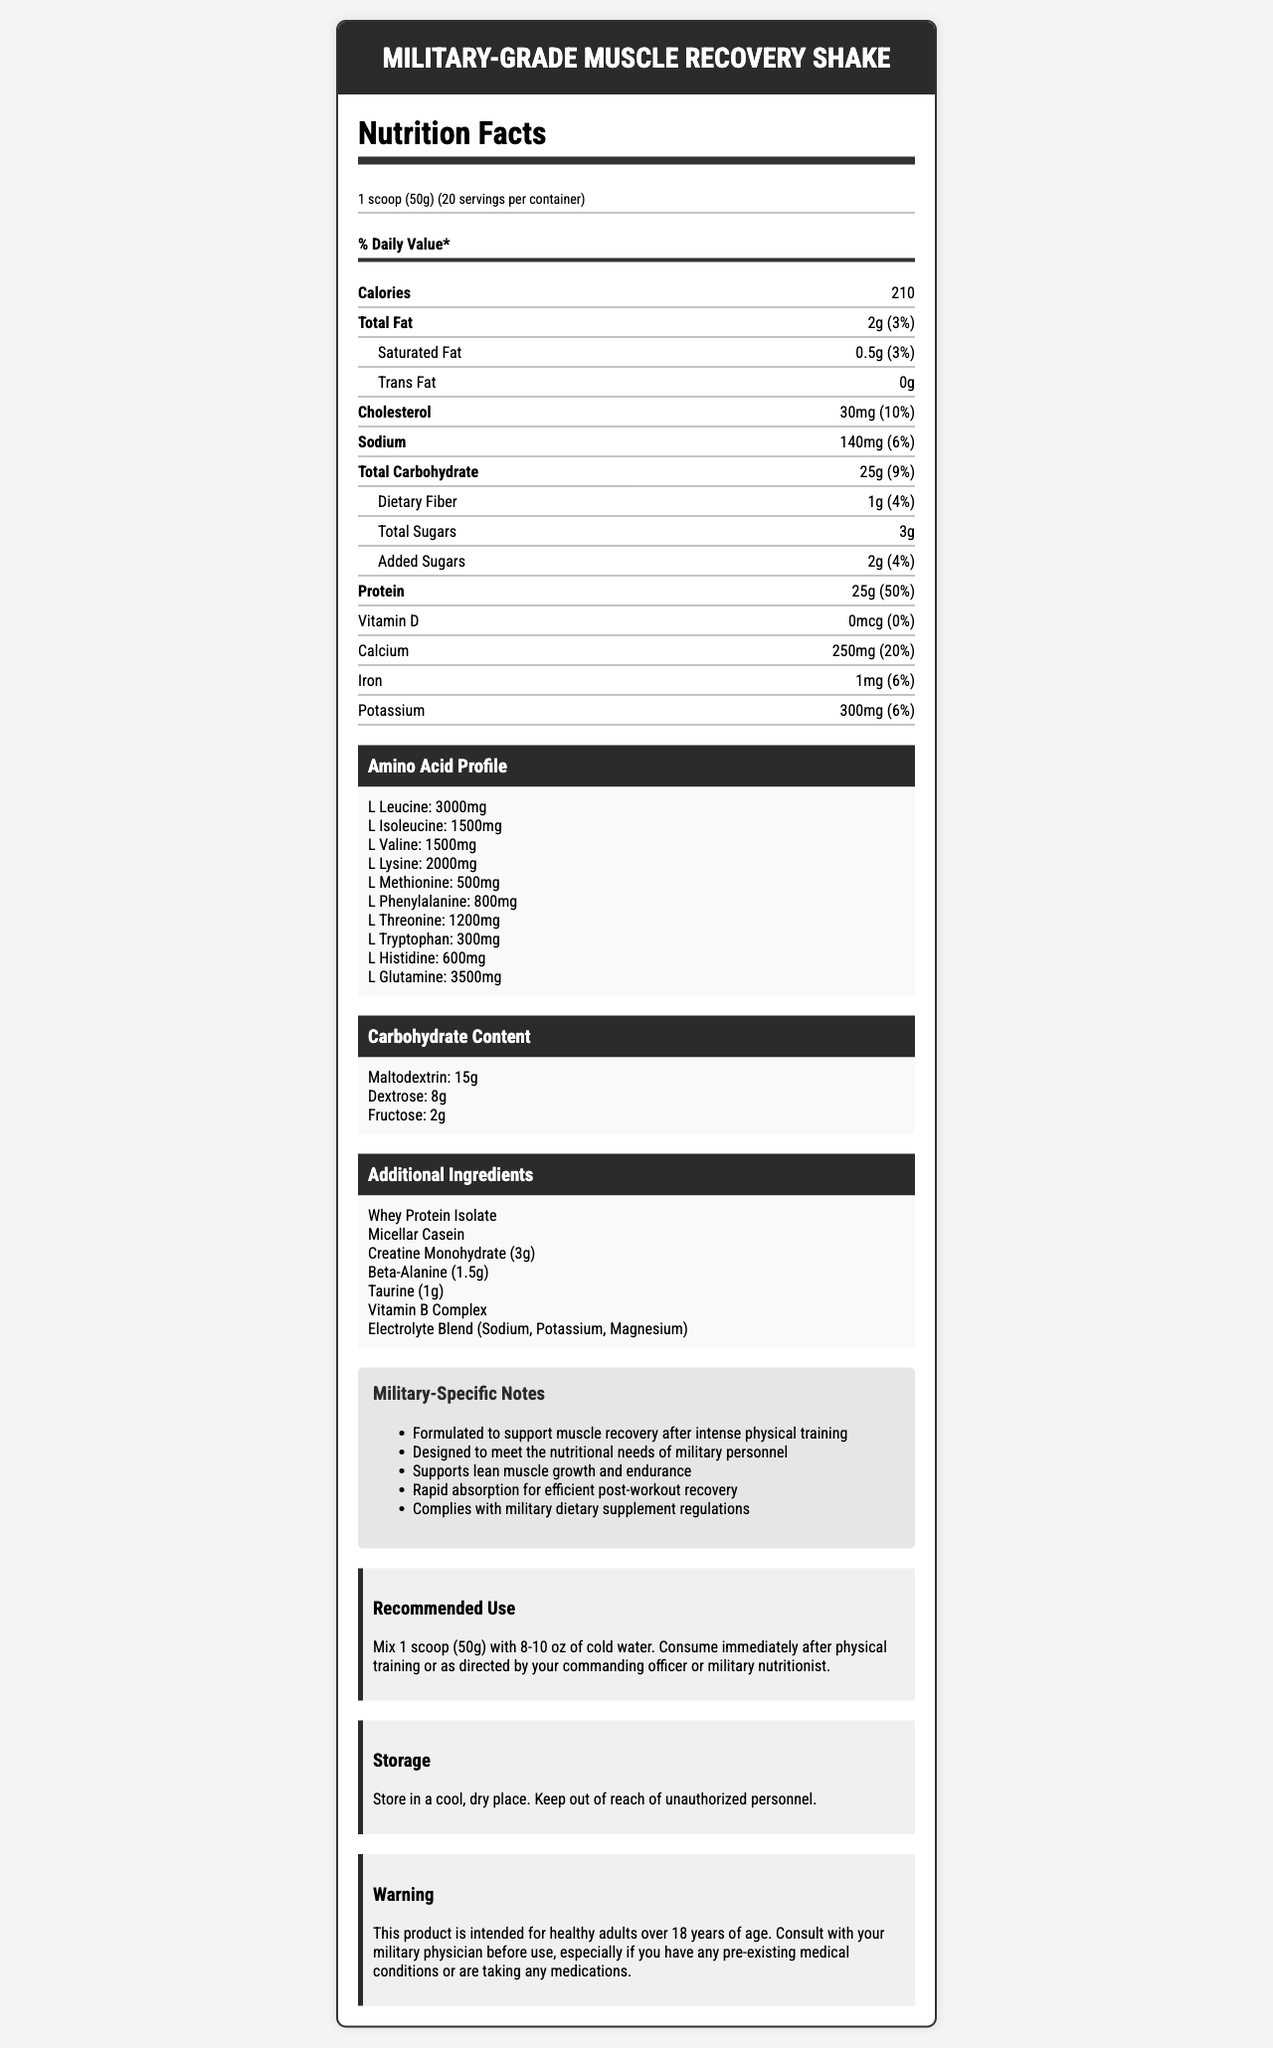how many servings are in the container? The document states that there are 20 servings per container.
Answer: 20 what is the serving size? The document lists the serving size as 1 scoop (50g).
Answer: 1 scoop (50g) how many calories are there per serving? Each serving contains 210 calories as stated in the document.
Answer: 210 how much protein is in one serving? The document mentions that each serving contains 25g of protein.
Answer: 25g what is the total carbohydrate content per serving? The total carbohydrate content per serving is 25g as indicated in the document.
Answer: 25g which amino acid has the highest concentration? L-Glutamine has the highest concentration at 3500mg, according to the amino acid profile.
Answer: L-Glutamine what is the main purpose of the Military-Grade Muscle Recovery Shake? A. Improve cardiovascular health B. Support muscle recovery and growth C. Aid in weight loss The document notes that the product is formulated to support muscle recovery after intense physical training and to meet the nutritional needs of military personnel, supporting lean muscle growth and endurance.
Answer: B what type of fat is completely absent in this product? A. Saturated Fat B. Trans Fat C. Unsaturated Fat Trans Fat is listed as "0g" in the document.
Answer: B does the product contain any added sugars? The document specifies that it contains 2g of added sugars.
Answer: Yes summarize the nutritional information and purpose of the Military-Grade Muscle Recovery Shake. The document details the nutritional content, including fats, carbohydrates, proteins, amino acid profile, and additional ingredients, and emphasizes its formulation for military needs such as muscle recovery, lean muscle growth, and endurance.
Answer: The Military-Grade Muscle Recovery Shake provides essential nutrients for muscle recovery and growth, including 25g of protein, 25g of carbohydrates, and key amino acids. It is designed to support military personnel in their physical training, providing rapid absorption and complying with dietary supplement regulations. what is the Vitamin D content in this shake? The document lists the Vitamin D content as 0mcg.
Answer: 0mcg does the product mention any specific use instructions for military personnel? The document mentions that it should be consumed immediately after physical training or as directed by a commanding officer or military nutritionist.
Answer: Yes compare the amounts of sodium and potassium per serving. The document lists sodium at 140mg and potassium at 300mg per serving.
Answer: Sodium: 140mg, Potassium: 300mg what is the total fat content per serving, and how much of it is saturated fat? The document provides the total fat content as 2g per serving and mentions that 0.5g of it is saturated fat.
Answer: Total Fat: 2g, Saturated Fat: 0.5g is iron content higher than calcium in this product? The iron content is 1mg, whereas the calcium content is 250mg, which is significantly higher.
Answer: No what is the amount of creatine monohydrate and beta-alanine included? The document lists creatine monohydrate at 3g and beta-alanine at 1.5g in the additional ingredients section.
Answer: Creatine Monohydrate: 3g, Beta-Alanine: 1.5g does the Military-Grade Muscle Recovery Shake contain whey protein isolate? The document lists Whey Protein Isolate as one of the additional ingredients.
Answer: Yes can we determine the price of the product from the information given? The document does not contain any information related to the price of the product.
Answer: Not enough information 